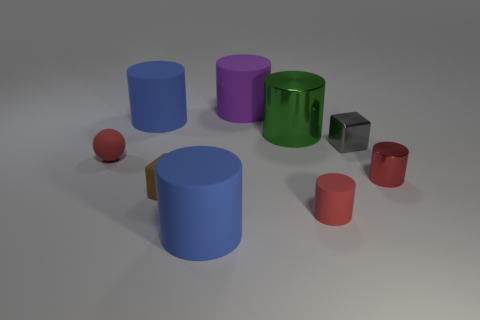There is a green object that is the same shape as the purple matte object; what size is it?
Your response must be concise. Large. There is a matte ball; is its color the same as the tiny cylinder that is behind the brown object?
Provide a short and direct response. Yes. Does the big green thing have the same material as the brown thing?
Provide a short and direct response. No. Is the color of the tiny matte object in front of the small brown thing the same as the tiny ball?
Offer a very short reply. Yes. There is a sphere that is the same color as the small matte cylinder; what is its material?
Offer a terse response. Rubber. There is a shiny cylinder on the left side of the gray cube; is there a blue matte cylinder that is in front of it?
Offer a very short reply. Yes. Are there any red spheres made of the same material as the brown object?
Keep it short and to the point. Yes. The tiny cylinder behind the tiny cube to the left of the large purple rubber object is made of what material?
Offer a very short reply. Metal. The cylinder that is both right of the purple thing and on the left side of the red matte cylinder is made of what material?
Provide a short and direct response. Metal. Are there an equal number of brown rubber things behind the gray block and red cylinders?
Your response must be concise. No. 